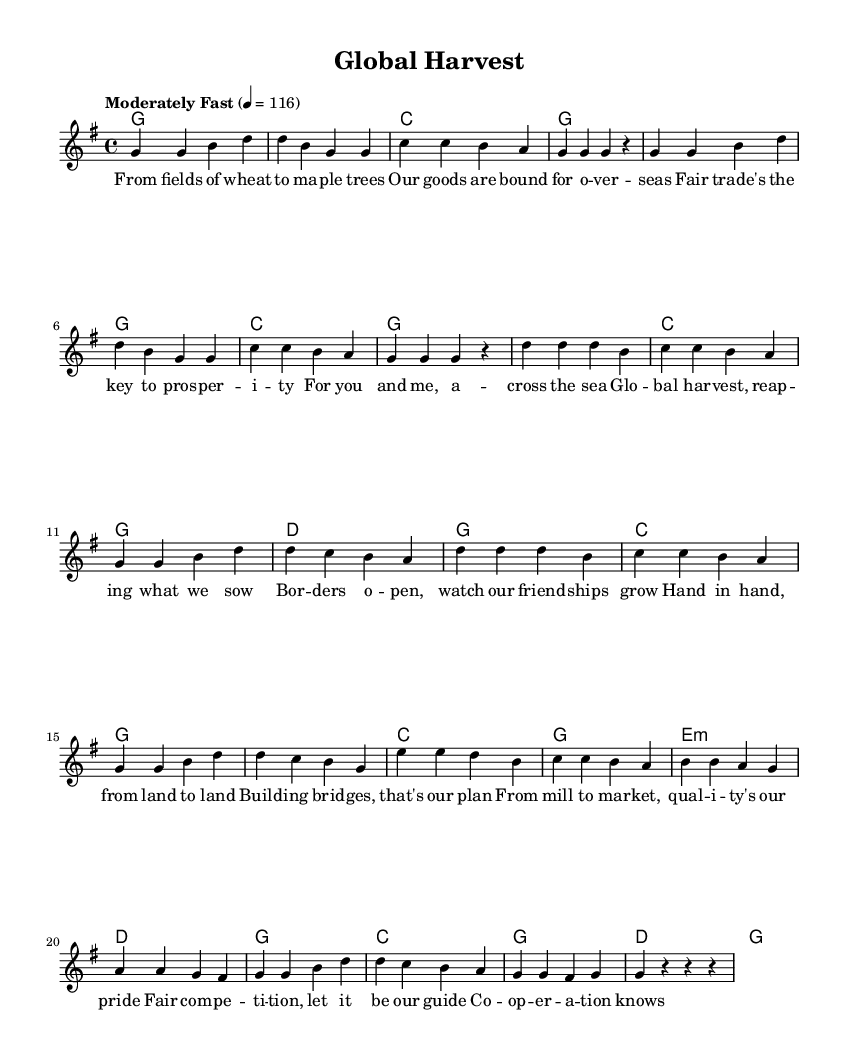What is the key signature of this music? The key signature is G major, which has one sharp (F#) indicated in the music.
Answer: G major What is the time signature of this music? The time signature is 4/4, which means there are four beats per measure. This is represented at the beginning of the sheet music.
Answer: 4/4 What is the tempo marking for this piece? The tempo marking is "Moderately Fast," with a beat of 116 per minute indicating the speed at which the music should be played.
Answer: Moderately Fast How many measures are in the chorus section? The chorus consists of four measures as seen in its lyrical structure, which can be identified by its distinct lyrical set in the sheet music.
Answer: Four What is the main theme of the lyrics? The main theme of the lyrics focuses on fair trade and international cooperation, emphasizing the importance of building relationships through trade practices.
Answer: Fair trade What musical form does this piece primarily follow? The piece follows a verse-chorus form, as evidenced by separate sections clearly laid out for verses and choruses in the lyrical representation.
Answer: Verse-chorus What is the harmony of the first chord played in this piece? The first chord indicated in the chord section is G major, which aligns with the melody that also starts with the note G.
Answer: G major 